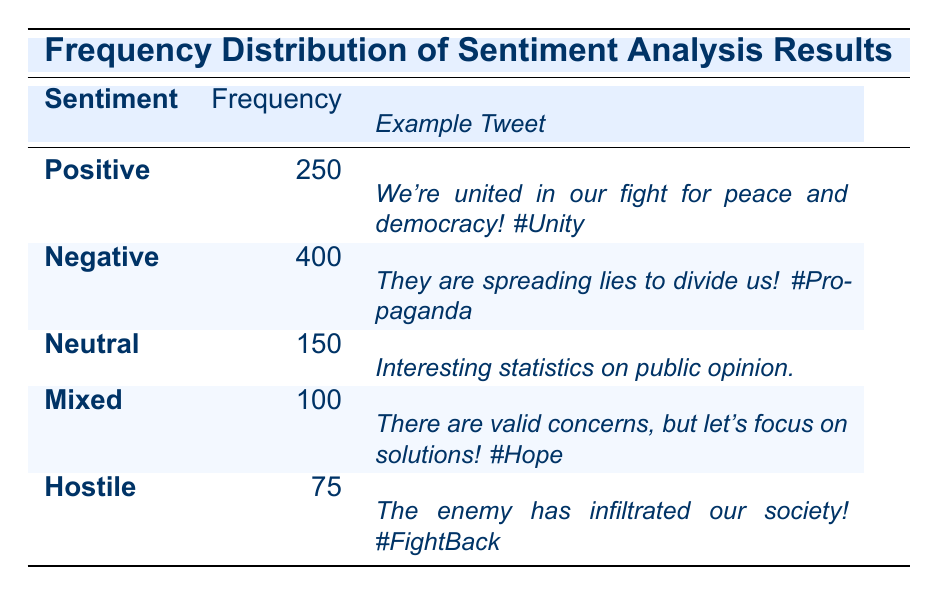What is the frequency of Negative sentiment tweets? The table explicitly states the frequency for Negative sentiment, which is listed in the appropriate row. It indicates that there are 400 tweets classified as Negative sentiment.
Answer: 400 Which sentiment has the second highest frequency? By examining the frequencies, Positive sentiment has 250, Negative has 400, Neutral has 150, Mixed has 100, and Hostile has 75. The second highest frequency is thus Positive since it follows Negative.
Answer: Positive What is the total number of tweets analyzed for sentiment? To find this total, we add the frequencies of all sentiments: 250 (Positive) + 400 (Negative) + 150 (Neutral) + 100 (Mixed) + 75 (Hostile) = 975. So the total number of tweets is 975.
Answer: 975 Is the frequency of Neutral sentiment greater than Mixed sentiment? The frequency for Neutral sentiment is 150 and for Mixed sentiment, it is 100. Since 150 is greater than 100, it confirms that Neutral sentiment has a higher frequency.
Answer: Yes What proportion of tweets are classified as Hostile? The frequency for Hostile sentiment is 75. To find the proportion, we divide the frequency of Hostile (75) by the total number of tweets (975). The calculation yields approximately 0.077 or 7.7%.
Answer: 7.7% If we combine Positive and Mixed sentiment frequencies, how do they compare to Negative sentiment? Positive has a frequency of 250 and Mixed has 100, so combined they equal 350 (250 + 100). Negative sentiment has a frequency of 400, which is higher than 350. Thus, Negative sentiment is greater when combining Positive and Mixed.
Answer: Negative is greater What is the average frequency across all sentiments? To find the average frequency, we sum the frequencies: 250 (Positive) + 400 (Negative) + 150 (Neutral) + 100 (Mixed) + 75 (Hostile) = 975. Since there are 5 sentiments, we then divide the total by 5: 975/5 = 195.
Answer: 195 Which sentiment has the least number of tweets? By reviewing the frequencies, Hostile has the lowest frequency with only 75 tweets.
Answer: Hostile Does the number of Neutral sentiment tweets exceed the combined number of Hostile and Mixed sentiment tweets? Neutral has 150 tweets, while Hostile has 75 and Mixed has 100. Combining Hostile and Mixed gives 175 (75 + 100), which is greater than the 150 for Neutral. Thus, Neutral does not exceed the combined total.
Answer: No 